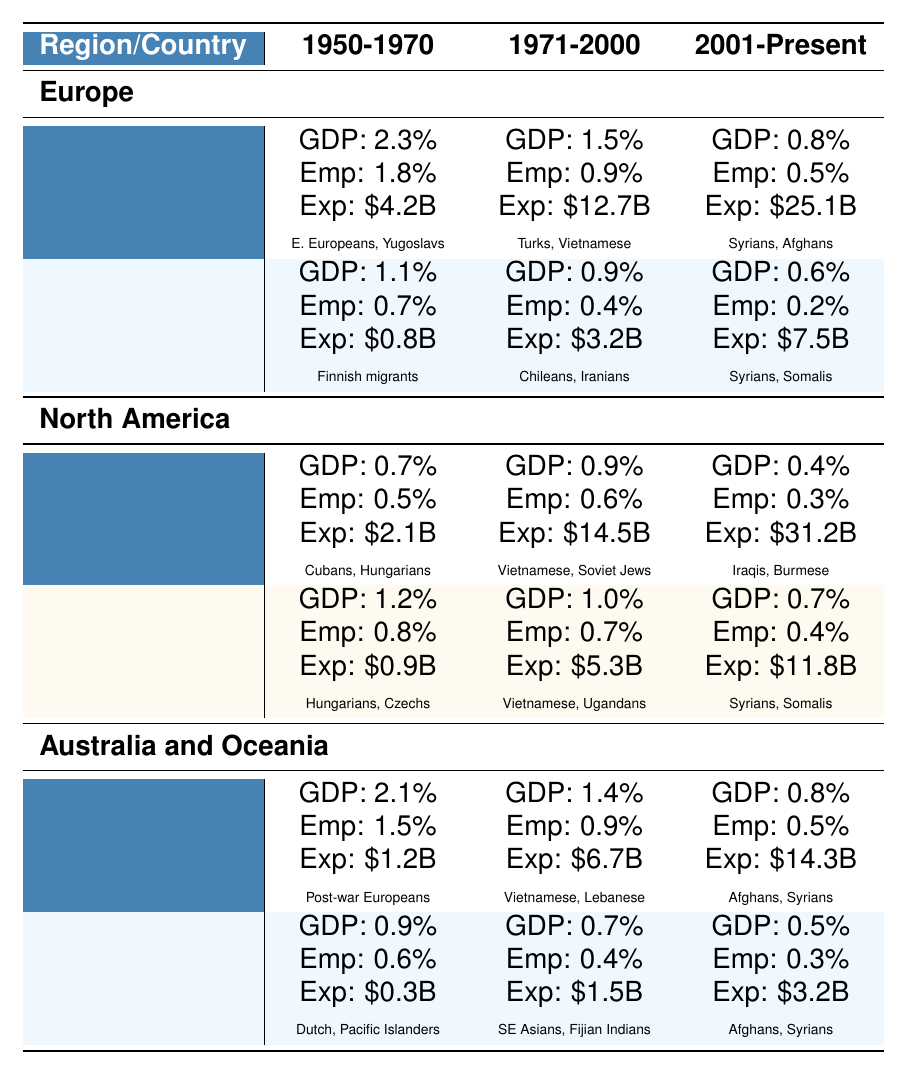What was the GDP impact of resettlement programs in Germany from 1971 to 2000? According to the table, the GDP impact in Germany for the period 1971 to 2000 is 1.5%.
Answer: 1.5% Which country had the highest government expenditure on resettlement programs from 2001 to present? The highest government expenditure in the table for the period 2001 to present is in the United States, which amounts to $31.2 billion.
Answer: United States What is the difference in the employment rate change between Canada for the periods of 1950-1970 and 2001-Present? The employment rate change for Canada in 1950-1970 is 0.8%, and in 2001-Present, it's 0.4%. Therefore, the difference is 0.8% - 0.4% = 0.4%.
Answer: 0.4% Did Sweden spend more on government expenditure for resettlement programs from 1950-1970 than Canada did in the same period? Sweden's government expenditure in 1950-1970 was $0.8 billion, while Canada's was $0.9 billion. Since 0.8 billion is less than 0.9 billion, the answer is no.
Answer: No What is the average GDP impact across all regions for the period 1971-2000? For 1971-2000, the GDP impacts are: Germany 1.5%, Sweden 0.9%, United States 0.9%, Canada 1.0%, Australia 1.4%, New Zealand 0.7%. The total is 1.5 + 0.9 + 0.9 + 1.0 + 1.4 + 0.7 = 6.4%. There are 6 regions; hence the average is 6.4% / 6 = 1.0667%.
Answer: 1.07% Which region had the greatest employment rate change for the period 1950-1970? The employment rate changes for 1950-1970 are: Germany 1.8%, Sweden 0.7%, United States 0.5%, Canada 0.8%, Australia 1.5%, New Zealand 0.6%. The highest value is 1.8%, so Germany had the greatest employment rate change.
Answer: Germany How many total billion USD was spent on government expenditure for resettlement programs in Australia from 1950 to present? The total government expenditure in Australia for 1950-1970 is $1.2 billion, for 1971-2000 is $6.7 billion, and for 2001-present is $14.3 billion. Summing them gives $1.2 + $6.7 + $14.3 = $22.2 billion.
Answer: $22.2 billion Can you list the major resettled group for Canada during the period 1971-2000? According to the table, the major resettled groups for Canada during 1971-2000 were the Vietnamese boat people and Ugandan Asians.
Answer: Vietnamese boat people, Ugandan Asians Which country had the lowest GDP impact for the period 2001-Present? Looking at the GDP impact for each country in the period 2001-Present: Germany 0.8%, Sweden 0.6%, United States 0.4%, Canada 0.7%, Australia 0.8%, New Zealand 0.5%. The lowest is 0.4% from the United States.
Answer: United States What trend is observed in the employment rate change in Sweden from 1971-2000 to 2001-Present? In Sweden, the employment rate change was 0.4% in 1971-2000 and decreased to 0.2% in 2001-Present. This shows a downward trend in the employment rate change.
Answer: Downward trend Was there an increase or decrease in government expenditure in Germany from the period 1971-2000 to 2001-Present? Government expenditure in Germany increased from $12.7 billion in 1971-2000 to $25.1 billion in 2001-Present, indicating an increase.
Answer: Increase 